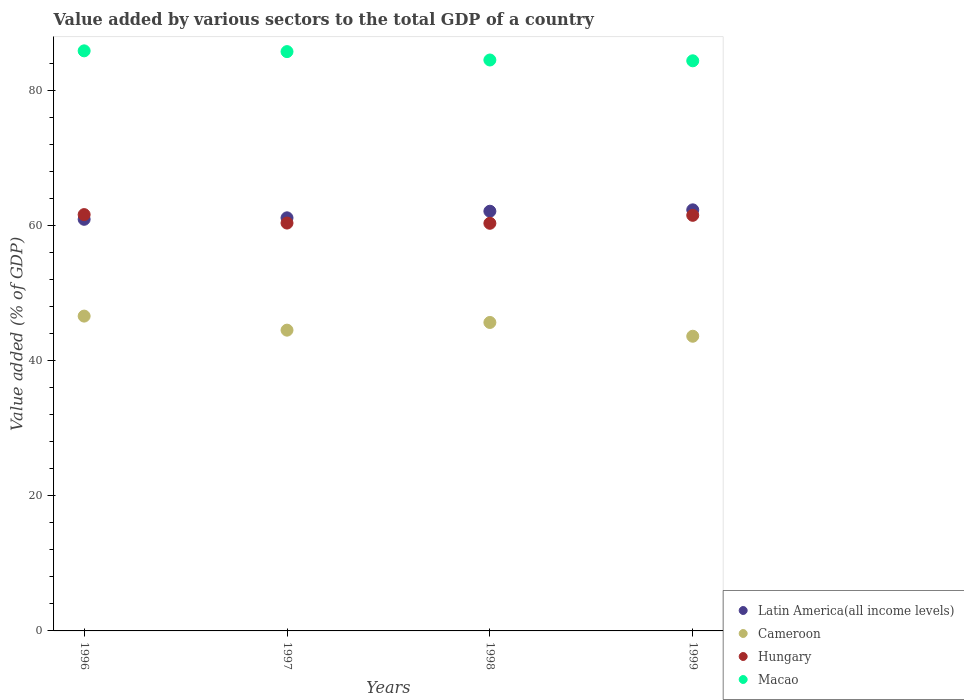What is the value added by various sectors to the total GDP in Macao in 1998?
Offer a very short reply. 84.49. Across all years, what is the maximum value added by various sectors to the total GDP in Macao?
Provide a succinct answer. 85.84. Across all years, what is the minimum value added by various sectors to the total GDP in Hungary?
Offer a terse response. 60.32. In which year was the value added by various sectors to the total GDP in Cameroon maximum?
Ensure brevity in your answer.  1996. What is the total value added by various sectors to the total GDP in Cameroon in the graph?
Provide a succinct answer. 180.35. What is the difference between the value added by various sectors to the total GDP in Hungary in 1998 and that in 1999?
Your answer should be very brief. -1.18. What is the difference between the value added by various sectors to the total GDP in Latin America(all income levels) in 1997 and the value added by various sectors to the total GDP in Macao in 1999?
Make the answer very short. -23.24. What is the average value added by various sectors to the total GDP in Macao per year?
Ensure brevity in your answer.  85.11. In the year 1999, what is the difference between the value added by various sectors to the total GDP in Cameroon and value added by various sectors to the total GDP in Hungary?
Offer a terse response. -17.89. In how many years, is the value added by various sectors to the total GDP in Cameroon greater than 52 %?
Ensure brevity in your answer.  0. What is the ratio of the value added by various sectors to the total GDP in Cameroon in 1996 to that in 1997?
Provide a short and direct response. 1.05. What is the difference between the highest and the second highest value added by various sectors to the total GDP in Macao?
Ensure brevity in your answer.  0.11. What is the difference between the highest and the lowest value added by various sectors to the total GDP in Hungary?
Make the answer very short. 1.29. In how many years, is the value added by various sectors to the total GDP in Macao greater than the average value added by various sectors to the total GDP in Macao taken over all years?
Ensure brevity in your answer.  2. Is the sum of the value added by various sectors to the total GDP in Macao in 1996 and 1997 greater than the maximum value added by various sectors to the total GDP in Cameroon across all years?
Provide a succinct answer. Yes. Is it the case that in every year, the sum of the value added by various sectors to the total GDP in Cameroon and value added by various sectors to the total GDP in Latin America(all income levels)  is greater than the sum of value added by various sectors to the total GDP in Macao and value added by various sectors to the total GDP in Hungary?
Your answer should be compact. No. Does the value added by various sectors to the total GDP in Hungary monotonically increase over the years?
Make the answer very short. No. What is the difference between two consecutive major ticks on the Y-axis?
Your answer should be compact. 20. Are the values on the major ticks of Y-axis written in scientific E-notation?
Give a very brief answer. No. What is the title of the graph?
Ensure brevity in your answer.  Value added by various sectors to the total GDP of a country. What is the label or title of the Y-axis?
Your response must be concise. Value added (% of GDP). What is the Value added (% of GDP) in Latin America(all income levels) in 1996?
Keep it short and to the point. 60.91. What is the Value added (% of GDP) in Cameroon in 1996?
Make the answer very short. 46.59. What is the Value added (% of GDP) of Hungary in 1996?
Offer a terse response. 61.61. What is the Value added (% of GDP) of Macao in 1996?
Make the answer very short. 85.84. What is the Value added (% of GDP) in Latin America(all income levels) in 1997?
Keep it short and to the point. 61.13. What is the Value added (% of GDP) in Cameroon in 1997?
Your response must be concise. 44.51. What is the Value added (% of GDP) of Hungary in 1997?
Offer a terse response. 60.36. What is the Value added (% of GDP) in Macao in 1997?
Provide a short and direct response. 85.73. What is the Value added (% of GDP) of Latin America(all income levels) in 1998?
Give a very brief answer. 62.11. What is the Value added (% of GDP) in Cameroon in 1998?
Your answer should be compact. 45.65. What is the Value added (% of GDP) of Hungary in 1998?
Keep it short and to the point. 60.32. What is the Value added (% of GDP) of Macao in 1998?
Offer a terse response. 84.49. What is the Value added (% of GDP) of Latin America(all income levels) in 1999?
Your response must be concise. 62.31. What is the Value added (% of GDP) of Cameroon in 1999?
Provide a short and direct response. 43.61. What is the Value added (% of GDP) in Hungary in 1999?
Keep it short and to the point. 61.5. What is the Value added (% of GDP) in Macao in 1999?
Give a very brief answer. 84.37. Across all years, what is the maximum Value added (% of GDP) in Latin America(all income levels)?
Provide a short and direct response. 62.31. Across all years, what is the maximum Value added (% of GDP) of Cameroon?
Offer a terse response. 46.59. Across all years, what is the maximum Value added (% of GDP) of Hungary?
Provide a succinct answer. 61.61. Across all years, what is the maximum Value added (% of GDP) in Macao?
Make the answer very short. 85.84. Across all years, what is the minimum Value added (% of GDP) in Latin America(all income levels)?
Offer a very short reply. 60.91. Across all years, what is the minimum Value added (% of GDP) of Cameroon?
Ensure brevity in your answer.  43.61. Across all years, what is the minimum Value added (% of GDP) of Hungary?
Ensure brevity in your answer.  60.32. Across all years, what is the minimum Value added (% of GDP) of Macao?
Provide a succinct answer. 84.37. What is the total Value added (% of GDP) of Latin America(all income levels) in the graph?
Ensure brevity in your answer.  246.47. What is the total Value added (% of GDP) of Cameroon in the graph?
Provide a short and direct response. 180.35. What is the total Value added (% of GDP) of Hungary in the graph?
Ensure brevity in your answer.  243.8. What is the total Value added (% of GDP) of Macao in the graph?
Provide a succinct answer. 340.43. What is the difference between the Value added (% of GDP) in Latin America(all income levels) in 1996 and that in 1997?
Provide a succinct answer. -0.22. What is the difference between the Value added (% of GDP) in Cameroon in 1996 and that in 1997?
Ensure brevity in your answer.  2.08. What is the difference between the Value added (% of GDP) in Hungary in 1996 and that in 1997?
Offer a terse response. 1.25. What is the difference between the Value added (% of GDP) of Macao in 1996 and that in 1997?
Offer a terse response. 0.11. What is the difference between the Value added (% of GDP) of Latin America(all income levels) in 1996 and that in 1998?
Provide a succinct answer. -1.19. What is the difference between the Value added (% of GDP) in Cameroon in 1996 and that in 1998?
Provide a short and direct response. 0.94. What is the difference between the Value added (% of GDP) in Hungary in 1996 and that in 1998?
Keep it short and to the point. 1.29. What is the difference between the Value added (% of GDP) of Macao in 1996 and that in 1998?
Your answer should be very brief. 1.35. What is the difference between the Value added (% of GDP) of Latin America(all income levels) in 1996 and that in 1999?
Provide a short and direct response. -1.4. What is the difference between the Value added (% of GDP) in Cameroon in 1996 and that in 1999?
Offer a very short reply. 2.98. What is the difference between the Value added (% of GDP) of Hungary in 1996 and that in 1999?
Your response must be concise. 0.11. What is the difference between the Value added (% of GDP) in Macao in 1996 and that in 1999?
Ensure brevity in your answer.  1.47. What is the difference between the Value added (% of GDP) in Latin America(all income levels) in 1997 and that in 1998?
Your answer should be very brief. -0.98. What is the difference between the Value added (% of GDP) in Cameroon in 1997 and that in 1998?
Your answer should be compact. -1.14. What is the difference between the Value added (% of GDP) of Hungary in 1997 and that in 1998?
Your answer should be very brief. 0.04. What is the difference between the Value added (% of GDP) of Macao in 1997 and that in 1998?
Your answer should be very brief. 1.24. What is the difference between the Value added (% of GDP) of Latin America(all income levels) in 1997 and that in 1999?
Offer a terse response. -1.18. What is the difference between the Value added (% of GDP) of Cameroon in 1997 and that in 1999?
Offer a terse response. 0.9. What is the difference between the Value added (% of GDP) of Hungary in 1997 and that in 1999?
Provide a short and direct response. -1.14. What is the difference between the Value added (% of GDP) in Macao in 1997 and that in 1999?
Make the answer very short. 1.36. What is the difference between the Value added (% of GDP) of Latin America(all income levels) in 1998 and that in 1999?
Keep it short and to the point. -0.2. What is the difference between the Value added (% of GDP) in Cameroon in 1998 and that in 1999?
Your response must be concise. 2.04. What is the difference between the Value added (% of GDP) of Hungary in 1998 and that in 1999?
Offer a terse response. -1.18. What is the difference between the Value added (% of GDP) in Macao in 1998 and that in 1999?
Give a very brief answer. 0.12. What is the difference between the Value added (% of GDP) in Latin America(all income levels) in 1996 and the Value added (% of GDP) in Cameroon in 1997?
Keep it short and to the point. 16.4. What is the difference between the Value added (% of GDP) in Latin America(all income levels) in 1996 and the Value added (% of GDP) in Hungary in 1997?
Provide a succinct answer. 0.55. What is the difference between the Value added (% of GDP) of Latin America(all income levels) in 1996 and the Value added (% of GDP) of Macao in 1997?
Give a very brief answer. -24.82. What is the difference between the Value added (% of GDP) in Cameroon in 1996 and the Value added (% of GDP) in Hungary in 1997?
Your answer should be compact. -13.77. What is the difference between the Value added (% of GDP) in Cameroon in 1996 and the Value added (% of GDP) in Macao in 1997?
Your answer should be compact. -39.14. What is the difference between the Value added (% of GDP) in Hungary in 1996 and the Value added (% of GDP) in Macao in 1997?
Give a very brief answer. -24.12. What is the difference between the Value added (% of GDP) of Latin America(all income levels) in 1996 and the Value added (% of GDP) of Cameroon in 1998?
Your answer should be compact. 15.27. What is the difference between the Value added (% of GDP) in Latin America(all income levels) in 1996 and the Value added (% of GDP) in Hungary in 1998?
Ensure brevity in your answer.  0.59. What is the difference between the Value added (% of GDP) in Latin America(all income levels) in 1996 and the Value added (% of GDP) in Macao in 1998?
Provide a succinct answer. -23.58. What is the difference between the Value added (% of GDP) of Cameroon in 1996 and the Value added (% of GDP) of Hungary in 1998?
Provide a succinct answer. -13.74. What is the difference between the Value added (% of GDP) in Cameroon in 1996 and the Value added (% of GDP) in Macao in 1998?
Offer a very short reply. -37.9. What is the difference between the Value added (% of GDP) in Hungary in 1996 and the Value added (% of GDP) in Macao in 1998?
Give a very brief answer. -22.88. What is the difference between the Value added (% of GDP) in Latin America(all income levels) in 1996 and the Value added (% of GDP) in Cameroon in 1999?
Offer a very short reply. 17.3. What is the difference between the Value added (% of GDP) of Latin America(all income levels) in 1996 and the Value added (% of GDP) of Hungary in 1999?
Your response must be concise. -0.59. What is the difference between the Value added (% of GDP) of Latin America(all income levels) in 1996 and the Value added (% of GDP) of Macao in 1999?
Your answer should be very brief. -23.46. What is the difference between the Value added (% of GDP) of Cameroon in 1996 and the Value added (% of GDP) of Hungary in 1999?
Your answer should be very brief. -14.91. What is the difference between the Value added (% of GDP) of Cameroon in 1996 and the Value added (% of GDP) of Macao in 1999?
Keep it short and to the point. -37.78. What is the difference between the Value added (% of GDP) of Hungary in 1996 and the Value added (% of GDP) of Macao in 1999?
Offer a terse response. -22.76. What is the difference between the Value added (% of GDP) of Latin America(all income levels) in 1997 and the Value added (% of GDP) of Cameroon in 1998?
Keep it short and to the point. 15.48. What is the difference between the Value added (% of GDP) in Latin America(all income levels) in 1997 and the Value added (% of GDP) in Hungary in 1998?
Offer a terse response. 0.81. What is the difference between the Value added (% of GDP) of Latin America(all income levels) in 1997 and the Value added (% of GDP) of Macao in 1998?
Give a very brief answer. -23.36. What is the difference between the Value added (% of GDP) of Cameroon in 1997 and the Value added (% of GDP) of Hungary in 1998?
Provide a short and direct response. -15.81. What is the difference between the Value added (% of GDP) in Cameroon in 1997 and the Value added (% of GDP) in Macao in 1998?
Your response must be concise. -39.98. What is the difference between the Value added (% of GDP) in Hungary in 1997 and the Value added (% of GDP) in Macao in 1998?
Your answer should be compact. -24.13. What is the difference between the Value added (% of GDP) in Latin America(all income levels) in 1997 and the Value added (% of GDP) in Cameroon in 1999?
Your answer should be very brief. 17.52. What is the difference between the Value added (% of GDP) in Latin America(all income levels) in 1997 and the Value added (% of GDP) in Hungary in 1999?
Ensure brevity in your answer.  -0.37. What is the difference between the Value added (% of GDP) of Latin America(all income levels) in 1997 and the Value added (% of GDP) of Macao in 1999?
Make the answer very short. -23.24. What is the difference between the Value added (% of GDP) of Cameroon in 1997 and the Value added (% of GDP) of Hungary in 1999?
Your response must be concise. -16.99. What is the difference between the Value added (% of GDP) of Cameroon in 1997 and the Value added (% of GDP) of Macao in 1999?
Provide a succinct answer. -39.86. What is the difference between the Value added (% of GDP) in Hungary in 1997 and the Value added (% of GDP) in Macao in 1999?
Your answer should be very brief. -24.01. What is the difference between the Value added (% of GDP) in Latin America(all income levels) in 1998 and the Value added (% of GDP) in Cameroon in 1999?
Give a very brief answer. 18.5. What is the difference between the Value added (% of GDP) in Latin America(all income levels) in 1998 and the Value added (% of GDP) in Hungary in 1999?
Your answer should be very brief. 0.61. What is the difference between the Value added (% of GDP) in Latin America(all income levels) in 1998 and the Value added (% of GDP) in Macao in 1999?
Keep it short and to the point. -22.26. What is the difference between the Value added (% of GDP) in Cameroon in 1998 and the Value added (% of GDP) in Hungary in 1999?
Your answer should be very brief. -15.86. What is the difference between the Value added (% of GDP) of Cameroon in 1998 and the Value added (% of GDP) of Macao in 1999?
Offer a terse response. -38.72. What is the difference between the Value added (% of GDP) in Hungary in 1998 and the Value added (% of GDP) in Macao in 1999?
Offer a very short reply. -24.05. What is the average Value added (% of GDP) in Latin America(all income levels) per year?
Give a very brief answer. 61.62. What is the average Value added (% of GDP) of Cameroon per year?
Make the answer very short. 45.09. What is the average Value added (% of GDP) in Hungary per year?
Keep it short and to the point. 60.95. What is the average Value added (% of GDP) in Macao per year?
Provide a succinct answer. 85.11. In the year 1996, what is the difference between the Value added (% of GDP) of Latin America(all income levels) and Value added (% of GDP) of Cameroon?
Your answer should be very brief. 14.32. In the year 1996, what is the difference between the Value added (% of GDP) of Latin America(all income levels) and Value added (% of GDP) of Hungary?
Keep it short and to the point. -0.7. In the year 1996, what is the difference between the Value added (% of GDP) in Latin America(all income levels) and Value added (% of GDP) in Macao?
Make the answer very short. -24.93. In the year 1996, what is the difference between the Value added (% of GDP) in Cameroon and Value added (% of GDP) in Hungary?
Your response must be concise. -15.02. In the year 1996, what is the difference between the Value added (% of GDP) of Cameroon and Value added (% of GDP) of Macao?
Ensure brevity in your answer.  -39.25. In the year 1996, what is the difference between the Value added (% of GDP) of Hungary and Value added (% of GDP) of Macao?
Give a very brief answer. -24.23. In the year 1997, what is the difference between the Value added (% of GDP) in Latin America(all income levels) and Value added (% of GDP) in Cameroon?
Ensure brevity in your answer.  16.62. In the year 1997, what is the difference between the Value added (% of GDP) of Latin America(all income levels) and Value added (% of GDP) of Hungary?
Provide a short and direct response. 0.77. In the year 1997, what is the difference between the Value added (% of GDP) in Latin America(all income levels) and Value added (% of GDP) in Macao?
Make the answer very short. -24.6. In the year 1997, what is the difference between the Value added (% of GDP) in Cameroon and Value added (% of GDP) in Hungary?
Offer a very short reply. -15.85. In the year 1997, what is the difference between the Value added (% of GDP) of Cameroon and Value added (% of GDP) of Macao?
Provide a succinct answer. -41.22. In the year 1997, what is the difference between the Value added (% of GDP) of Hungary and Value added (% of GDP) of Macao?
Your answer should be compact. -25.37. In the year 1998, what is the difference between the Value added (% of GDP) in Latin America(all income levels) and Value added (% of GDP) in Cameroon?
Offer a terse response. 16.46. In the year 1998, what is the difference between the Value added (% of GDP) of Latin America(all income levels) and Value added (% of GDP) of Hungary?
Offer a terse response. 1.78. In the year 1998, what is the difference between the Value added (% of GDP) of Latin America(all income levels) and Value added (% of GDP) of Macao?
Your answer should be compact. -22.38. In the year 1998, what is the difference between the Value added (% of GDP) of Cameroon and Value added (% of GDP) of Hungary?
Offer a very short reply. -14.68. In the year 1998, what is the difference between the Value added (% of GDP) of Cameroon and Value added (% of GDP) of Macao?
Make the answer very short. -38.84. In the year 1998, what is the difference between the Value added (% of GDP) in Hungary and Value added (% of GDP) in Macao?
Offer a very short reply. -24.17. In the year 1999, what is the difference between the Value added (% of GDP) of Latin America(all income levels) and Value added (% of GDP) of Cameroon?
Keep it short and to the point. 18.7. In the year 1999, what is the difference between the Value added (% of GDP) of Latin America(all income levels) and Value added (% of GDP) of Hungary?
Your response must be concise. 0.81. In the year 1999, what is the difference between the Value added (% of GDP) of Latin America(all income levels) and Value added (% of GDP) of Macao?
Your answer should be compact. -22.06. In the year 1999, what is the difference between the Value added (% of GDP) of Cameroon and Value added (% of GDP) of Hungary?
Offer a very short reply. -17.89. In the year 1999, what is the difference between the Value added (% of GDP) of Cameroon and Value added (% of GDP) of Macao?
Offer a terse response. -40.76. In the year 1999, what is the difference between the Value added (% of GDP) of Hungary and Value added (% of GDP) of Macao?
Ensure brevity in your answer.  -22.87. What is the ratio of the Value added (% of GDP) of Cameroon in 1996 to that in 1997?
Keep it short and to the point. 1.05. What is the ratio of the Value added (% of GDP) in Hungary in 1996 to that in 1997?
Make the answer very short. 1.02. What is the ratio of the Value added (% of GDP) of Latin America(all income levels) in 1996 to that in 1998?
Give a very brief answer. 0.98. What is the ratio of the Value added (% of GDP) of Cameroon in 1996 to that in 1998?
Give a very brief answer. 1.02. What is the ratio of the Value added (% of GDP) in Hungary in 1996 to that in 1998?
Give a very brief answer. 1.02. What is the ratio of the Value added (% of GDP) of Macao in 1996 to that in 1998?
Provide a succinct answer. 1.02. What is the ratio of the Value added (% of GDP) in Latin America(all income levels) in 1996 to that in 1999?
Offer a very short reply. 0.98. What is the ratio of the Value added (% of GDP) in Cameroon in 1996 to that in 1999?
Provide a short and direct response. 1.07. What is the ratio of the Value added (% of GDP) in Hungary in 1996 to that in 1999?
Make the answer very short. 1. What is the ratio of the Value added (% of GDP) in Macao in 1996 to that in 1999?
Make the answer very short. 1.02. What is the ratio of the Value added (% of GDP) of Latin America(all income levels) in 1997 to that in 1998?
Your answer should be compact. 0.98. What is the ratio of the Value added (% of GDP) in Cameroon in 1997 to that in 1998?
Offer a very short reply. 0.98. What is the ratio of the Value added (% of GDP) of Macao in 1997 to that in 1998?
Provide a short and direct response. 1.01. What is the ratio of the Value added (% of GDP) of Cameroon in 1997 to that in 1999?
Your answer should be very brief. 1.02. What is the ratio of the Value added (% of GDP) of Hungary in 1997 to that in 1999?
Provide a succinct answer. 0.98. What is the ratio of the Value added (% of GDP) in Macao in 1997 to that in 1999?
Your answer should be compact. 1.02. What is the ratio of the Value added (% of GDP) in Latin America(all income levels) in 1998 to that in 1999?
Your answer should be compact. 1. What is the ratio of the Value added (% of GDP) in Cameroon in 1998 to that in 1999?
Your answer should be compact. 1.05. What is the ratio of the Value added (% of GDP) of Hungary in 1998 to that in 1999?
Provide a short and direct response. 0.98. What is the difference between the highest and the second highest Value added (% of GDP) of Latin America(all income levels)?
Your answer should be very brief. 0.2. What is the difference between the highest and the second highest Value added (% of GDP) in Cameroon?
Offer a very short reply. 0.94. What is the difference between the highest and the second highest Value added (% of GDP) of Hungary?
Give a very brief answer. 0.11. What is the difference between the highest and the second highest Value added (% of GDP) of Macao?
Offer a very short reply. 0.11. What is the difference between the highest and the lowest Value added (% of GDP) of Latin America(all income levels)?
Your answer should be very brief. 1.4. What is the difference between the highest and the lowest Value added (% of GDP) of Cameroon?
Make the answer very short. 2.98. What is the difference between the highest and the lowest Value added (% of GDP) in Hungary?
Give a very brief answer. 1.29. What is the difference between the highest and the lowest Value added (% of GDP) in Macao?
Make the answer very short. 1.47. 